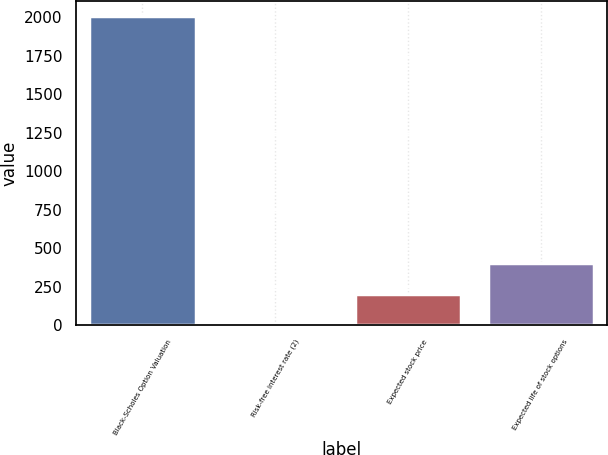Convert chart to OTSL. <chart><loc_0><loc_0><loc_500><loc_500><bar_chart><fcel>Black-Scholes Option Valuation<fcel>Risk-free interest rate (2)<fcel>Expected stock price<fcel>Expected life of stock options<nl><fcel>2004<fcel>3.3<fcel>203.37<fcel>403.44<nl></chart> 